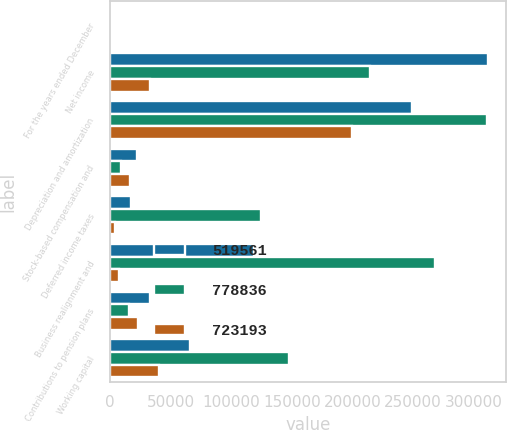Convert chart to OTSL. <chart><loc_0><loc_0><loc_500><loc_500><stacked_bar_chart><ecel><fcel>For the years ended December<fcel>Net income<fcel>Depreciation and amortization<fcel>Stock-based compensation and<fcel>Deferred income taxes<fcel>Business realignment and<fcel>Contributions to pension plans<fcel>Working capital<nl><fcel>519561<fcel>2008<fcel>311405<fcel>249491<fcel>22196<fcel>17125<fcel>119117<fcel>32759<fcel>65791<nl><fcel>778836<fcel>2007<fcel>214154<fcel>310925<fcel>9526<fcel>124276<fcel>267653<fcel>15836<fcel>148019<nl><fcel>723193<fcel>2006<fcel>32759<fcel>199911<fcel>16323<fcel>4173<fcel>7573<fcel>23570<fcel>40553<nl></chart> 